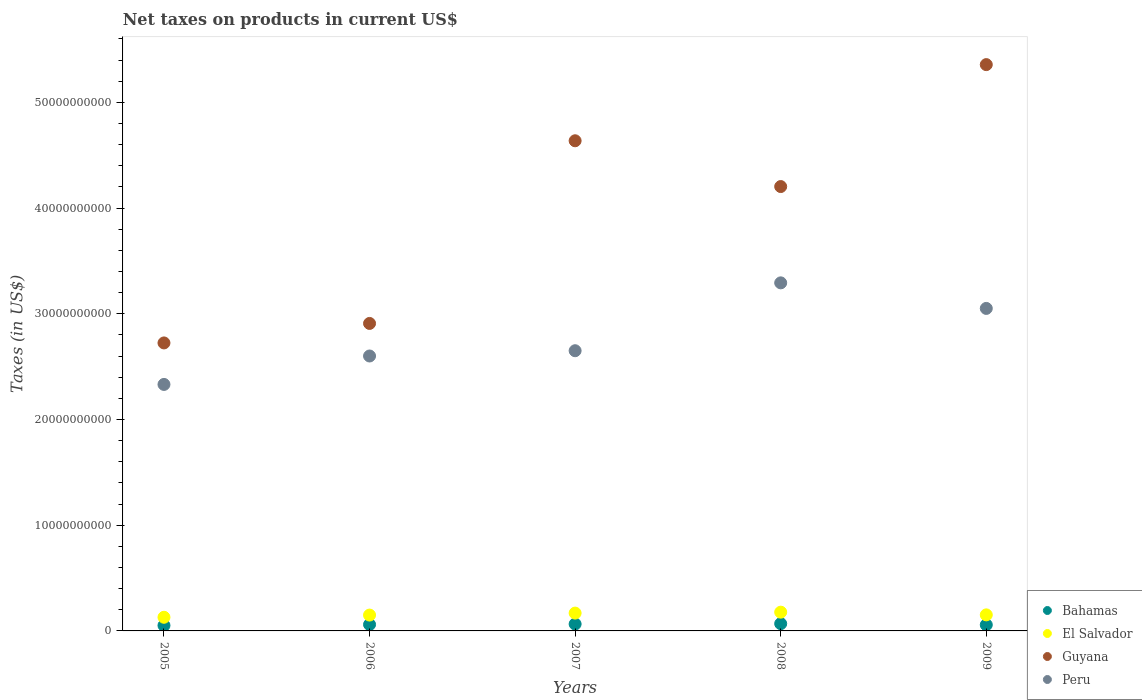How many different coloured dotlines are there?
Your response must be concise. 4. What is the net taxes on products in Peru in 2008?
Make the answer very short. 3.29e+1. Across all years, what is the maximum net taxes on products in Guyana?
Give a very brief answer. 5.36e+1. Across all years, what is the minimum net taxes on products in El Salvador?
Give a very brief answer. 1.29e+09. In which year was the net taxes on products in Guyana minimum?
Provide a succinct answer. 2005. What is the total net taxes on products in El Salvador in the graph?
Offer a very short reply. 7.77e+09. What is the difference between the net taxes on products in Peru in 2005 and that in 2006?
Your answer should be very brief. -2.69e+09. What is the difference between the net taxes on products in Bahamas in 2006 and the net taxes on products in Guyana in 2009?
Keep it short and to the point. -5.30e+1. What is the average net taxes on products in Bahamas per year?
Provide a succinct answer. 6.07e+08. In the year 2007, what is the difference between the net taxes on products in El Salvador and net taxes on products in Guyana?
Your answer should be compact. -4.47e+1. What is the ratio of the net taxes on products in Bahamas in 2005 to that in 2009?
Provide a short and direct response. 0.89. What is the difference between the highest and the second highest net taxes on products in Peru?
Make the answer very short. 2.42e+09. What is the difference between the highest and the lowest net taxes on products in El Salvador?
Your response must be concise. 4.83e+08. In how many years, is the net taxes on products in El Salvador greater than the average net taxes on products in El Salvador taken over all years?
Provide a succinct answer. 2. Is the sum of the net taxes on products in Guyana in 2006 and 2008 greater than the maximum net taxes on products in Bahamas across all years?
Give a very brief answer. Yes. Is it the case that in every year, the sum of the net taxes on products in Peru and net taxes on products in Guyana  is greater than the net taxes on products in El Salvador?
Your answer should be very brief. Yes. Does the net taxes on products in Bahamas monotonically increase over the years?
Your answer should be compact. No. Is the net taxes on products in Peru strictly greater than the net taxes on products in Bahamas over the years?
Keep it short and to the point. Yes. How many years are there in the graph?
Offer a very short reply. 5. Are the values on the major ticks of Y-axis written in scientific E-notation?
Keep it short and to the point. No. Does the graph contain any zero values?
Provide a succinct answer. No. Where does the legend appear in the graph?
Offer a terse response. Bottom right. How many legend labels are there?
Provide a short and direct response. 4. What is the title of the graph?
Your answer should be very brief. Net taxes on products in current US$. What is the label or title of the X-axis?
Give a very brief answer. Years. What is the label or title of the Y-axis?
Provide a succinct answer. Taxes (in US$). What is the Taxes (in US$) in Bahamas in 2005?
Keep it short and to the point. 5.16e+08. What is the Taxes (in US$) in El Salvador in 2005?
Your answer should be compact. 1.29e+09. What is the Taxes (in US$) of Guyana in 2005?
Ensure brevity in your answer.  2.72e+1. What is the Taxes (in US$) of Peru in 2005?
Offer a terse response. 2.33e+1. What is the Taxes (in US$) of Bahamas in 2006?
Make the answer very short. 6.06e+08. What is the Taxes (in US$) in El Salvador in 2006?
Your answer should be compact. 1.50e+09. What is the Taxes (in US$) of Guyana in 2006?
Your answer should be very brief. 2.91e+1. What is the Taxes (in US$) of Peru in 2006?
Ensure brevity in your answer.  2.60e+1. What is the Taxes (in US$) of Bahamas in 2007?
Ensure brevity in your answer.  6.51e+08. What is the Taxes (in US$) in El Salvador in 2007?
Your response must be concise. 1.69e+09. What is the Taxes (in US$) of Guyana in 2007?
Keep it short and to the point. 4.64e+1. What is the Taxes (in US$) in Peru in 2007?
Provide a short and direct response. 2.65e+1. What is the Taxes (in US$) in Bahamas in 2008?
Keep it short and to the point. 6.86e+08. What is the Taxes (in US$) in El Salvador in 2008?
Your answer should be compact. 1.77e+09. What is the Taxes (in US$) of Guyana in 2008?
Your answer should be compact. 4.20e+1. What is the Taxes (in US$) of Peru in 2008?
Your answer should be compact. 3.29e+1. What is the Taxes (in US$) of Bahamas in 2009?
Make the answer very short. 5.76e+08. What is the Taxes (in US$) in El Salvador in 2009?
Offer a terse response. 1.52e+09. What is the Taxes (in US$) in Guyana in 2009?
Your answer should be very brief. 5.36e+1. What is the Taxes (in US$) in Peru in 2009?
Keep it short and to the point. 3.05e+1. Across all years, what is the maximum Taxes (in US$) in Bahamas?
Provide a succinct answer. 6.86e+08. Across all years, what is the maximum Taxes (in US$) in El Salvador?
Offer a terse response. 1.77e+09. Across all years, what is the maximum Taxes (in US$) in Guyana?
Offer a terse response. 5.36e+1. Across all years, what is the maximum Taxes (in US$) of Peru?
Keep it short and to the point. 3.29e+1. Across all years, what is the minimum Taxes (in US$) in Bahamas?
Offer a terse response. 5.16e+08. Across all years, what is the minimum Taxes (in US$) in El Salvador?
Offer a terse response. 1.29e+09. Across all years, what is the minimum Taxes (in US$) of Guyana?
Provide a short and direct response. 2.72e+1. Across all years, what is the minimum Taxes (in US$) in Peru?
Keep it short and to the point. 2.33e+1. What is the total Taxes (in US$) of Bahamas in the graph?
Ensure brevity in your answer.  3.03e+09. What is the total Taxes (in US$) in El Salvador in the graph?
Make the answer very short. 7.77e+09. What is the total Taxes (in US$) in Guyana in the graph?
Give a very brief answer. 1.98e+11. What is the total Taxes (in US$) in Peru in the graph?
Provide a short and direct response. 1.39e+11. What is the difference between the Taxes (in US$) in Bahamas in 2005 and that in 2006?
Give a very brief answer. -9.00e+07. What is the difference between the Taxes (in US$) of El Salvador in 2005 and that in 2006?
Provide a succinct answer. -2.07e+08. What is the difference between the Taxes (in US$) of Guyana in 2005 and that in 2006?
Keep it short and to the point. -1.84e+09. What is the difference between the Taxes (in US$) of Peru in 2005 and that in 2006?
Your answer should be compact. -2.69e+09. What is the difference between the Taxes (in US$) in Bahamas in 2005 and that in 2007?
Offer a very short reply. -1.35e+08. What is the difference between the Taxes (in US$) in El Salvador in 2005 and that in 2007?
Your answer should be very brief. -3.94e+08. What is the difference between the Taxes (in US$) of Guyana in 2005 and that in 2007?
Ensure brevity in your answer.  -1.91e+1. What is the difference between the Taxes (in US$) of Peru in 2005 and that in 2007?
Offer a terse response. -3.19e+09. What is the difference between the Taxes (in US$) of Bahamas in 2005 and that in 2008?
Make the answer very short. -1.70e+08. What is the difference between the Taxes (in US$) of El Salvador in 2005 and that in 2008?
Make the answer very short. -4.83e+08. What is the difference between the Taxes (in US$) in Guyana in 2005 and that in 2008?
Your response must be concise. -1.48e+1. What is the difference between the Taxes (in US$) in Peru in 2005 and that in 2008?
Provide a short and direct response. -9.61e+09. What is the difference between the Taxes (in US$) of Bahamas in 2005 and that in 2009?
Ensure brevity in your answer.  -6.07e+07. What is the difference between the Taxes (in US$) of El Salvador in 2005 and that in 2009?
Provide a short and direct response. -2.28e+08. What is the difference between the Taxes (in US$) of Guyana in 2005 and that in 2009?
Give a very brief answer. -2.63e+1. What is the difference between the Taxes (in US$) in Peru in 2005 and that in 2009?
Provide a short and direct response. -7.19e+09. What is the difference between the Taxes (in US$) in Bahamas in 2006 and that in 2007?
Provide a succinct answer. -4.49e+07. What is the difference between the Taxes (in US$) in El Salvador in 2006 and that in 2007?
Keep it short and to the point. -1.87e+08. What is the difference between the Taxes (in US$) of Guyana in 2006 and that in 2007?
Your response must be concise. -1.73e+1. What is the difference between the Taxes (in US$) of Peru in 2006 and that in 2007?
Provide a short and direct response. -4.99e+08. What is the difference between the Taxes (in US$) of Bahamas in 2006 and that in 2008?
Ensure brevity in your answer.  -7.99e+07. What is the difference between the Taxes (in US$) of El Salvador in 2006 and that in 2008?
Offer a very short reply. -2.76e+08. What is the difference between the Taxes (in US$) in Guyana in 2006 and that in 2008?
Your answer should be very brief. -1.29e+1. What is the difference between the Taxes (in US$) of Peru in 2006 and that in 2008?
Ensure brevity in your answer.  -6.92e+09. What is the difference between the Taxes (in US$) in Bahamas in 2006 and that in 2009?
Keep it short and to the point. 2.93e+07. What is the difference between the Taxes (in US$) of El Salvador in 2006 and that in 2009?
Offer a terse response. -2.01e+07. What is the difference between the Taxes (in US$) in Guyana in 2006 and that in 2009?
Provide a short and direct response. -2.45e+1. What is the difference between the Taxes (in US$) of Peru in 2006 and that in 2009?
Your answer should be compact. -4.50e+09. What is the difference between the Taxes (in US$) in Bahamas in 2007 and that in 2008?
Offer a terse response. -3.50e+07. What is the difference between the Taxes (in US$) of El Salvador in 2007 and that in 2008?
Provide a short and direct response. -8.86e+07. What is the difference between the Taxes (in US$) in Guyana in 2007 and that in 2008?
Make the answer very short. 4.33e+09. What is the difference between the Taxes (in US$) of Peru in 2007 and that in 2008?
Offer a terse response. -6.42e+09. What is the difference between the Taxes (in US$) of Bahamas in 2007 and that in 2009?
Offer a terse response. 7.42e+07. What is the difference between the Taxes (in US$) of El Salvador in 2007 and that in 2009?
Your answer should be very brief. 1.67e+08. What is the difference between the Taxes (in US$) in Guyana in 2007 and that in 2009?
Ensure brevity in your answer.  -7.20e+09. What is the difference between the Taxes (in US$) in Peru in 2007 and that in 2009?
Provide a succinct answer. -4.00e+09. What is the difference between the Taxes (in US$) in Bahamas in 2008 and that in 2009?
Make the answer very short. 1.09e+08. What is the difference between the Taxes (in US$) of El Salvador in 2008 and that in 2009?
Give a very brief answer. 2.56e+08. What is the difference between the Taxes (in US$) in Guyana in 2008 and that in 2009?
Offer a very short reply. -1.15e+1. What is the difference between the Taxes (in US$) of Peru in 2008 and that in 2009?
Keep it short and to the point. 2.42e+09. What is the difference between the Taxes (in US$) in Bahamas in 2005 and the Taxes (in US$) in El Salvador in 2006?
Provide a succinct answer. -9.83e+08. What is the difference between the Taxes (in US$) of Bahamas in 2005 and the Taxes (in US$) of Guyana in 2006?
Make the answer very short. -2.86e+1. What is the difference between the Taxes (in US$) of Bahamas in 2005 and the Taxes (in US$) of Peru in 2006?
Make the answer very short. -2.55e+1. What is the difference between the Taxes (in US$) in El Salvador in 2005 and the Taxes (in US$) in Guyana in 2006?
Ensure brevity in your answer.  -2.78e+1. What is the difference between the Taxes (in US$) of El Salvador in 2005 and the Taxes (in US$) of Peru in 2006?
Your answer should be very brief. -2.47e+1. What is the difference between the Taxes (in US$) in Guyana in 2005 and the Taxes (in US$) in Peru in 2006?
Offer a terse response. 1.24e+09. What is the difference between the Taxes (in US$) in Bahamas in 2005 and the Taxes (in US$) in El Salvador in 2007?
Provide a succinct answer. -1.17e+09. What is the difference between the Taxes (in US$) in Bahamas in 2005 and the Taxes (in US$) in Guyana in 2007?
Keep it short and to the point. -4.58e+1. What is the difference between the Taxes (in US$) of Bahamas in 2005 and the Taxes (in US$) of Peru in 2007?
Your answer should be very brief. -2.60e+1. What is the difference between the Taxes (in US$) in El Salvador in 2005 and the Taxes (in US$) in Guyana in 2007?
Your answer should be compact. -4.51e+1. What is the difference between the Taxes (in US$) in El Salvador in 2005 and the Taxes (in US$) in Peru in 2007?
Your response must be concise. -2.52e+1. What is the difference between the Taxes (in US$) in Guyana in 2005 and the Taxes (in US$) in Peru in 2007?
Ensure brevity in your answer.  7.37e+08. What is the difference between the Taxes (in US$) in Bahamas in 2005 and the Taxes (in US$) in El Salvador in 2008?
Provide a succinct answer. -1.26e+09. What is the difference between the Taxes (in US$) of Bahamas in 2005 and the Taxes (in US$) of Guyana in 2008?
Ensure brevity in your answer.  -4.15e+1. What is the difference between the Taxes (in US$) in Bahamas in 2005 and the Taxes (in US$) in Peru in 2008?
Offer a terse response. -3.24e+1. What is the difference between the Taxes (in US$) of El Salvador in 2005 and the Taxes (in US$) of Guyana in 2008?
Provide a succinct answer. -4.07e+1. What is the difference between the Taxes (in US$) in El Salvador in 2005 and the Taxes (in US$) in Peru in 2008?
Your response must be concise. -3.16e+1. What is the difference between the Taxes (in US$) of Guyana in 2005 and the Taxes (in US$) of Peru in 2008?
Ensure brevity in your answer.  -5.68e+09. What is the difference between the Taxes (in US$) in Bahamas in 2005 and the Taxes (in US$) in El Salvador in 2009?
Your response must be concise. -1.00e+09. What is the difference between the Taxes (in US$) in Bahamas in 2005 and the Taxes (in US$) in Guyana in 2009?
Make the answer very short. -5.30e+1. What is the difference between the Taxes (in US$) in Bahamas in 2005 and the Taxes (in US$) in Peru in 2009?
Give a very brief answer. -3.00e+1. What is the difference between the Taxes (in US$) of El Salvador in 2005 and the Taxes (in US$) of Guyana in 2009?
Offer a terse response. -5.23e+1. What is the difference between the Taxes (in US$) in El Salvador in 2005 and the Taxes (in US$) in Peru in 2009?
Keep it short and to the point. -2.92e+1. What is the difference between the Taxes (in US$) of Guyana in 2005 and the Taxes (in US$) of Peru in 2009?
Your answer should be compact. -3.26e+09. What is the difference between the Taxes (in US$) in Bahamas in 2006 and the Taxes (in US$) in El Salvador in 2007?
Provide a short and direct response. -1.08e+09. What is the difference between the Taxes (in US$) in Bahamas in 2006 and the Taxes (in US$) in Guyana in 2007?
Your response must be concise. -4.58e+1. What is the difference between the Taxes (in US$) in Bahamas in 2006 and the Taxes (in US$) in Peru in 2007?
Provide a short and direct response. -2.59e+1. What is the difference between the Taxes (in US$) in El Salvador in 2006 and the Taxes (in US$) in Guyana in 2007?
Your response must be concise. -4.49e+1. What is the difference between the Taxes (in US$) of El Salvador in 2006 and the Taxes (in US$) of Peru in 2007?
Give a very brief answer. -2.50e+1. What is the difference between the Taxes (in US$) of Guyana in 2006 and the Taxes (in US$) of Peru in 2007?
Offer a very short reply. 2.58e+09. What is the difference between the Taxes (in US$) of Bahamas in 2006 and the Taxes (in US$) of El Salvador in 2008?
Provide a short and direct response. -1.17e+09. What is the difference between the Taxes (in US$) in Bahamas in 2006 and the Taxes (in US$) in Guyana in 2008?
Offer a terse response. -4.14e+1. What is the difference between the Taxes (in US$) in Bahamas in 2006 and the Taxes (in US$) in Peru in 2008?
Offer a terse response. -3.23e+1. What is the difference between the Taxes (in US$) in El Salvador in 2006 and the Taxes (in US$) in Guyana in 2008?
Ensure brevity in your answer.  -4.05e+1. What is the difference between the Taxes (in US$) of El Salvador in 2006 and the Taxes (in US$) of Peru in 2008?
Your answer should be compact. -3.14e+1. What is the difference between the Taxes (in US$) of Guyana in 2006 and the Taxes (in US$) of Peru in 2008?
Offer a terse response. -3.84e+09. What is the difference between the Taxes (in US$) of Bahamas in 2006 and the Taxes (in US$) of El Salvador in 2009?
Offer a very short reply. -9.13e+08. What is the difference between the Taxes (in US$) in Bahamas in 2006 and the Taxes (in US$) in Guyana in 2009?
Your response must be concise. -5.30e+1. What is the difference between the Taxes (in US$) of Bahamas in 2006 and the Taxes (in US$) of Peru in 2009?
Offer a terse response. -2.99e+1. What is the difference between the Taxes (in US$) in El Salvador in 2006 and the Taxes (in US$) in Guyana in 2009?
Your response must be concise. -5.21e+1. What is the difference between the Taxes (in US$) of El Salvador in 2006 and the Taxes (in US$) of Peru in 2009?
Ensure brevity in your answer.  -2.90e+1. What is the difference between the Taxes (in US$) of Guyana in 2006 and the Taxes (in US$) of Peru in 2009?
Provide a short and direct response. -1.42e+09. What is the difference between the Taxes (in US$) in Bahamas in 2007 and the Taxes (in US$) in El Salvador in 2008?
Your response must be concise. -1.12e+09. What is the difference between the Taxes (in US$) of Bahamas in 2007 and the Taxes (in US$) of Guyana in 2008?
Offer a very short reply. -4.14e+1. What is the difference between the Taxes (in US$) in Bahamas in 2007 and the Taxes (in US$) in Peru in 2008?
Offer a very short reply. -3.23e+1. What is the difference between the Taxes (in US$) of El Salvador in 2007 and the Taxes (in US$) of Guyana in 2008?
Keep it short and to the point. -4.03e+1. What is the difference between the Taxes (in US$) of El Salvador in 2007 and the Taxes (in US$) of Peru in 2008?
Provide a short and direct response. -3.12e+1. What is the difference between the Taxes (in US$) in Guyana in 2007 and the Taxes (in US$) in Peru in 2008?
Give a very brief answer. 1.34e+1. What is the difference between the Taxes (in US$) of Bahamas in 2007 and the Taxes (in US$) of El Salvador in 2009?
Ensure brevity in your answer.  -8.68e+08. What is the difference between the Taxes (in US$) of Bahamas in 2007 and the Taxes (in US$) of Guyana in 2009?
Provide a succinct answer. -5.29e+1. What is the difference between the Taxes (in US$) in Bahamas in 2007 and the Taxes (in US$) in Peru in 2009?
Ensure brevity in your answer.  -2.99e+1. What is the difference between the Taxes (in US$) of El Salvador in 2007 and the Taxes (in US$) of Guyana in 2009?
Make the answer very short. -5.19e+1. What is the difference between the Taxes (in US$) in El Salvador in 2007 and the Taxes (in US$) in Peru in 2009?
Ensure brevity in your answer.  -2.88e+1. What is the difference between the Taxes (in US$) in Guyana in 2007 and the Taxes (in US$) in Peru in 2009?
Make the answer very short. 1.59e+1. What is the difference between the Taxes (in US$) in Bahamas in 2008 and the Taxes (in US$) in El Salvador in 2009?
Your response must be concise. -8.33e+08. What is the difference between the Taxes (in US$) of Bahamas in 2008 and the Taxes (in US$) of Guyana in 2009?
Offer a very short reply. -5.29e+1. What is the difference between the Taxes (in US$) in Bahamas in 2008 and the Taxes (in US$) in Peru in 2009?
Your answer should be compact. -2.98e+1. What is the difference between the Taxes (in US$) in El Salvador in 2008 and the Taxes (in US$) in Guyana in 2009?
Provide a succinct answer. -5.18e+1. What is the difference between the Taxes (in US$) in El Salvador in 2008 and the Taxes (in US$) in Peru in 2009?
Provide a succinct answer. -2.87e+1. What is the difference between the Taxes (in US$) in Guyana in 2008 and the Taxes (in US$) in Peru in 2009?
Give a very brief answer. 1.15e+1. What is the average Taxes (in US$) in Bahamas per year?
Keep it short and to the point. 6.07e+08. What is the average Taxes (in US$) of El Salvador per year?
Provide a short and direct response. 1.55e+09. What is the average Taxes (in US$) in Guyana per year?
Your answer should be very brief. 3.97e+1. What is the average Taxes (in US$) of Peru per year?
Offer a very short reply. 2.78e+1. In the year 2005, what is the difference between the Taxes (in US$) in Bahamas and Taxes (in US$) in El Salvador?
Provide a succinct answer. -7.75e+08. In the year 2005, what is the difference between the Taxes (in US$) of Bahamas and Taxes (in US$) of Guyana?
Ensure brevity in your answer.  -2.67e+1. In the year 2005, what is the difference between the Taxes (in US$) in Bahamas and Taxes (in US$) in Peru?
Your answer should be compact. -2.28e+1. In the year 2005, what is the difference between the Taxes (in US$) in El Salvador and Taxes (in US$) in Guyana?
Give a very brief answer. -2.59e+1. In the year 2005, what is the difference between the Taxes (in US$) of El Salvador and Taxes (in US$) of Peru?
Make the answer very short. -2.20e+1. In the year 2005, what is the difference between the Taxes (in US$) of Guyana and Taxes (in US$) of Peru?
Offer a terse response. 3.93e+09. In the year 2006, what is the difference between the Taxes (in US$) in Bahamas and Taxes (in US$) in El Salvador?
Give a very brief answer. -8.93e+08. In the year 2006, what is the difference between the Taxes (in US$) in Bahamas and Taxes (in US$) in Guyana?
Make the answer very short. -2.85e+1. In the year 2006, what is the difference between the Taxes (in US$) of Bahamas and Taxes (in US$) of Peru?
Your answer should be very brief. -2.54e+1. In the year 2006, what is the difference between the Taxes (in US$) of El Salvador and Taxes (in US$) of Guyana?
Provide a short and direct response. -2.76e+1. In the year 2006, what is the difference between the Taxes (in US$) in El Salvador and Taxes (in US$) in Peru?
Provide a succinct answer. -2.45e+1. In the year 2006, what is the difference between the Taxes (in US$) in Guyana and Taxes (in US$) in Peru?
Your answer should be compact. 3.08e+09. In the year 2007, what is the difference between the Taxes (in US$) in Bahamas and Taxes (in US$) in El Salvador?
Your answer should be compact. -1.04e+09. In the year 2007, what is the difference between the Taxes (in US$) in Bahamas and Taxes (in US$) in Guyana?
Ensure brevity in your answer.  -4.57e+1. In the year 2007, what is the difference between the Taxes (in US$) in Bahamas and Taxes (in US$) in Peru?
Give a very brief answer. -2.59e+1. In the year 2007, what is the difference between the Taxes (in US$) in El Salvador and Taxes (in US$) in Guyana?
Offer a terse response. -4.47e+1. In the year 2007, what is the difference between the Taxes (in US$) of El Salvador and Taxes (in US$) of Peru?
Your answer should be compact. -2.48e+1. In the year 2007, what is the difference between the Taxes (in US$) of Guyana and Taxes (in US$) of Peru?
Ensure brevity in your answer.  1.99e+1. In the year 2008, what is the difference between the Taxes (in US$) of Bahamas and Taxes (in US$) of El Salvador?
Your response must be concise. -1.09e+09. In the year 2008, what is the difference between the Taxes (in US$) in Bahamas and Taxes (in US$) in Guyana?
Your answer should be compact. -4.13e+1. In the year 2008, what is the difference between the Taxes (in US$) of Bahamas and Taxes (in US$) of Peru?
Keep it short and to the point. -3.22e+1. In the year 2008, what is the difference between the Taxes (in US$) of El Salvador and Taxes (in US$) of Guyana?
Keep it short and to the point. -4.03e+1. In the year 2008, what is the difference between the Taxes (in US$) of El Salvador and Taxes (in US$) of Peru?
Give a very brief answer. -3.11e+1. In the year 2008, what is the difference between the Taxes (in US$) in Guyana and Taxes (in US$) in Peru?
Offer a very short reply. 9.11e+09. In the year 2009, what is the difference between the Taxes (in US$) of Bahamas and Taxes (in US$) of El Salvador?
Make the answer very short. -9.42e+08. In the year 2009, what is the difference between the Taxes (in US$) of Bahamas and Taxes (in US$) of Guyana?
Give a very brief answer. -5.30e+1. In the year 2009, what is the difference between the Taxes (in US$) in Bahamas and Taxes (in US$) in Peru?
Provide a succinct answer. -2.99e+1. In the year 2009, what is the difference between the Taxes (in US$) in El Salvador and Taxes (in US$) in Guyana?
Keep it short and to the point. -5.20e+1. In the year 2009, what is the difference between the Taxes (in US$) in El Salvador and Taxes (in US$) in Peru?
Your answer should be very brief. -2.90e+1. In the year 2009, what is the difference between the Taxes (in US$) in Guyana and Taxes (in US$) in Peru?
Provide a short and direct response. 2.31e+1. What is the ratio of the Taxes (in US$) in Bahamas in 2005 to that in 2006?
Your answer should be compact. 0.85. What is the ratio of the Taxes (in US$) of El Salvador in 2005 to that in 2006?
Make the answer very short. 0.86. What is the ratio of the Taxes (in US$) of Guyana in 2005 to that in 2006?
Keep it short and to the point. 0.94. What is the ratio of the Taxes (in US$) in Peru in 2005 to that in 2006?
Your answer should be very brief. 0.9. What is the ratio of the Taxes (in US$) of Bahamas in 2005 to that in 2007?
Provide a short and direct response. 0.79. What is the ratio of the Taxes (in US$) of El Salvador in 2005 to that in 2007?
Provide a short and direct response. 0.77. What is the ratio of the Taxes (in US$) in Guyana in 2005 to that in 2007?
Your response must be concise. 0.59. What is the ratio of the Taxes (in US$) in Peru in 2005 to that in 2007?
Ensure brevity in your answer.  0.88. What is the ratio of the Taxes (in US$) in Bahamas in 2005 to that in 2008?
Your answer should be compact. 0.75. What is the ratio of the Taxes (in US$) in El Salvador in 2005 to that in 2008?
Your answer should be very brief. 0.73. What is the ratio of the Taxes (in US$) of Guyana in 2005 to that in 2008?
Give a very brief answer. 0.65. What is the ratio of the Taxes (in US$) in Peru in 2005 to that in 2008?
Keep it short and to the point. 0.71. What is the ratio of the Taxes (in US$) in Bahamas in 2005 to that in 2009?
Ensure brevity in your answer.  0.89. What is the ratio of the Taxes (in US$) in El Salvador in 2005 to that in 2009?
Offer a very short reply. 0.85. What is the ratio of the Taxes (in US$) in Guyana in 2005 to that in 2009?
Your response must be concise. 0.51. What is the ratio of the Taxes (in US$) in Peru in 2005 to that in 2009?
Offer a terse response. 0.76. What is the ratio of the Taxes (in US$) of Bahamas in 2006 to that in 2007?
Your response must be concise. 0.93. What is the ratio of the Taxes (in US$) in El Salvador in 2006 to that in 2007?
Offer a terse response. 0.89. What is the ratio of the Taxes (in US$) in Guyana in 2006 to that in 2007?
Provide a succinct answer. 0.63. What is the ratio of the Taxes (in US$) of Peru in 2006 to that in 2007?
Provide a short and direct response. 0.98. What is the ratio of the Taxes (in US$) in Bahamas in 2006 to that in 2008?
Offer a terse response. 0.88. What is the ratio of the Taxes (in US$) of El Salvador in 2006 to that in 2008?
Give a very brief answer. 0.84. What is the ratio of the Taxes (in US$) in Guyana in 2006 to that in 2008?
Your answer should be compact. 0.69. What is the ratio of the Taxes (in US$) in Peru in 2006 to that in 2008?
Your answer should be compact. 0.79. What is the ratio of the Taxes (in US$) in Bahamas in 2006 to that in 2009?
Give a very brief answer. 1.05. What is the ratio of the Taxes (in US$) in El Salvador in 2006 to that in 2009?
Your response must be concise. 0.99. What is the ratio of the Taxes (in US$) of Guyana in 2006 to that in 2009?
Offer a very short reply. 0.54. What is the ratio of the Taxes (in US$) of Peru in 2006 to that in 2009?
Keep it short and to the point. 0.85. What is the ratio of the Taxes (in US$) in Bahamas in 2007 to that in 2008?
Offer a very short reply. 0.95. What is the ratio of the Taxes (in US$) in El Salvador in 2007 to that in 2008?
Provide a short and direct response. 0.95. What is the ratio of the Taxes (in US$) of Guyana in 2007 to that in 2008?
Your answer should be very brief. 1.1. What is the ratio of the Taxes (in US$) in Peru in 2007 to that in 2008?
Provide a succinct answer. 0.81. What is the ratio of the Taxes (in US$) of Bahamas in 2007 to that in 2009?
Make the answer very short. 1.13. What is the ratio of the Taxes (in US$) in El Salvador in 2007 to that in 2009?
Keep it short and to the point. 1.11. What is the ratio of the Taxes (in US$) of Guyana in 2007 to that in 2009?
Offer a very short reply. 0.87. What is the ratio of the Taxes (in US$) in Peru in 2007 to that in 2009?
Offer a very short reply. 0.87. What is the ratio of the Taxes (in US$) of Bahamas in 2008 to that in 2009?
Make the answer very short. 1.19. What is the ratio of the Taxes (in US$) in El Salvador in 2008 to that in 2009?
Make the answer very short. 1.17. What is the ratio of the Taxes (in US$) in Guyana in 2008 to that in 2009?
Offer a very short reply. 0.78. What is the ratio of the Taxes (in US$) in Peru in 2008 to that in 2009?
Offer a very short reply. 1.08. What is the difference between the highest and the second highest Taxes (in US$) in Bahamas?
Offer a terse response. 3.50e+07. What is the difference between the highest and the second highest Taxes (in US$) of El Salvador?
Offer a very short reply. 8.86e+07. What is the difference between the highest and the second highest Taxes (in US$) in Guyana?
Give a very brief answer. 7.20e+09. What is the difference between the highest and the second highest Taxes (in US$) of Peru?
Make the answer very short. 2.42e+09. What is the difference between the highest and the lowest Taxes (in US$) in Bahamas?
Keep it short and to the point. 1.70e+08. What is the difference between the highest and the lowest Taxes (in US$) in El Salvador?
Make the answer very short. 4.83e+08. What is the difference between the highest and the lowest Taxes (in US$) of Guyana?
Make the answer very short. 2.63e+1. What is the difference between the highest and the lowest Taxes (in US$) in Peru?
Make the answer very short. 9.61e+09. 